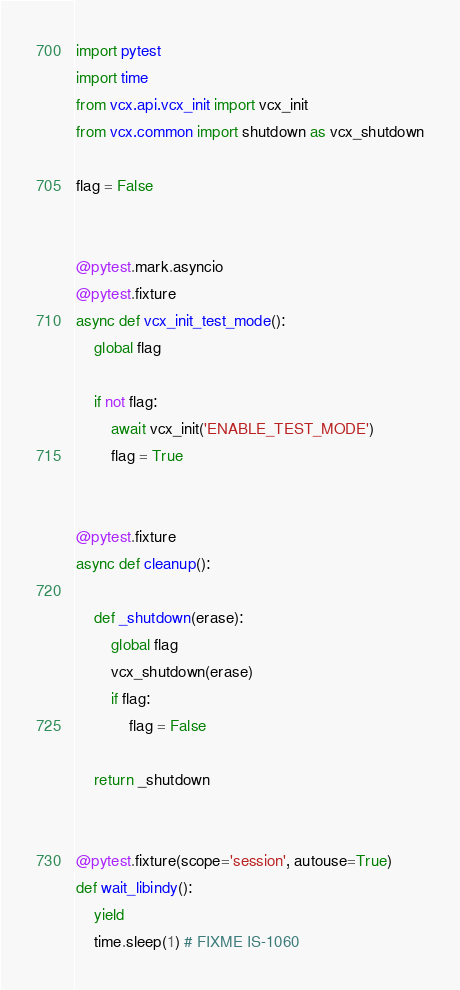Convert code to text. <code><loc_0><loc_0><loc_500><loc_500><_Python_>import pytest
import time
from vcx.api.vcx_init import vcx_init
from vcx.common import shutdown as vcx_shutdown

flag = False


@pytest.mark.asyncio
@pytest.fixture
async def vcx_init_test_mode():
    global flag

    if not flag:
        await vcx_init('ENABLE_TEST_MODE')
        flag = True


@pytest.fixture
async def cleanup():

    def _shutdown(erase):
        global flag
        vcx_shutdown(erase)
        if flag:
            flag = False

    return _shutdown


@pytest.fixture(scope='session', autouse=True)
def wait_libindy():
    yield
    time.sleep(1) # FIXME IS-1060</code> 